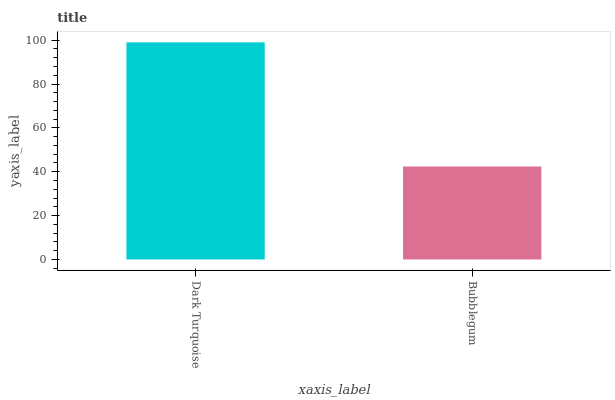Is Bubblegum the minimum?
Answer yes or no. Yes. Is Dark Turquoise the maximum?
Answer yes or no. Yes. Is Bubblegum the maximum?
Answer yes or no. No. Is Dark Turquoise greater than Bubblegum?
Answer yes or no. Yes. Is Bubblegum less than Dark Turquoise?
Answer yes or no. Yes. Is Bubblegum greater than Dark Turquoise?
Answer yes or no. No. Is Dark Turquoise less than Bubblegum?
Answer yes or no. No. Is Dark Turquoise the high median?
Answer yes or no. Yes. Is Bubblegum the low median?
Answer yes or no. Yes. Is Bubblegum the high median?
Answer yes or no. No. Is Dark Turquoise the low median?
Answer yes or no. No. 